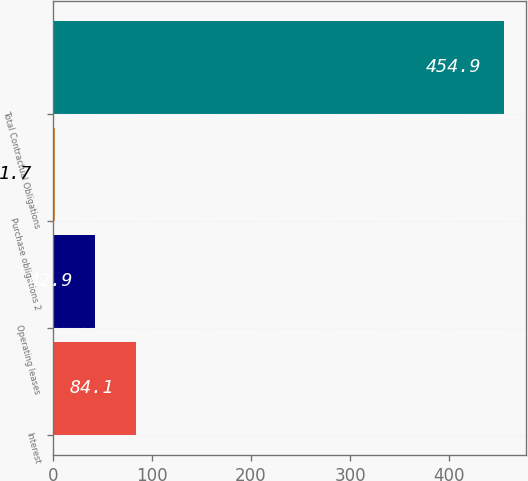<chart> <loc_0><loc_0><loc_500><loc_500><bar_chart><fcel>Interest<fcel>Operating leases<fcel>Purchase obligations 2<fcel>Total Contractual Obligations<nl><fcel>84.1<fcel>42.9<fcel>1.7<fcel>454.9<nl></chart> 